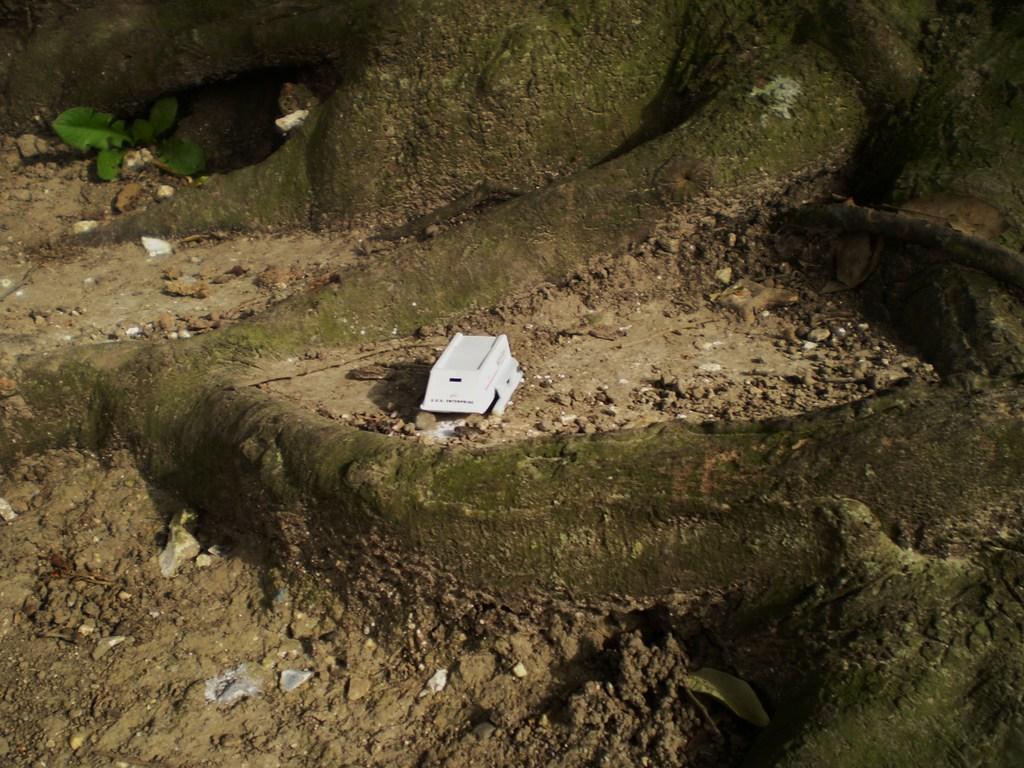Could you give a brief overview of what you see in this image? This picture is clicked outside. In the center there is a white color object on the ground and we can see the gravels, leaves and the roots of the tree. 